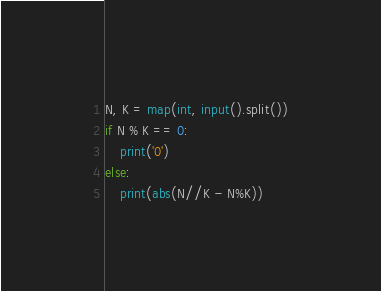Convert code to text. <code><loc_0><loc_0><loc_500><loc_500><_Python_>N, K = map(int, input().split())
if N % K == 0:
    print('0')
else:
    print(abs(N//K - N%K))</code> 